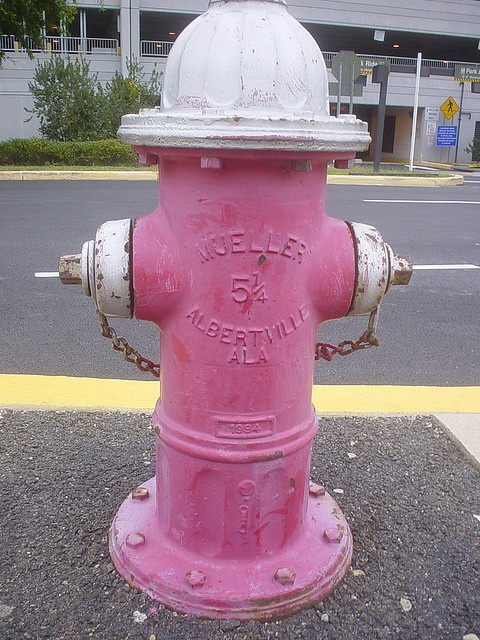Describe the objects in this image and their specific colors. I can see a fire hydrant in gray, violet, lavender, and brown tones in this image. 